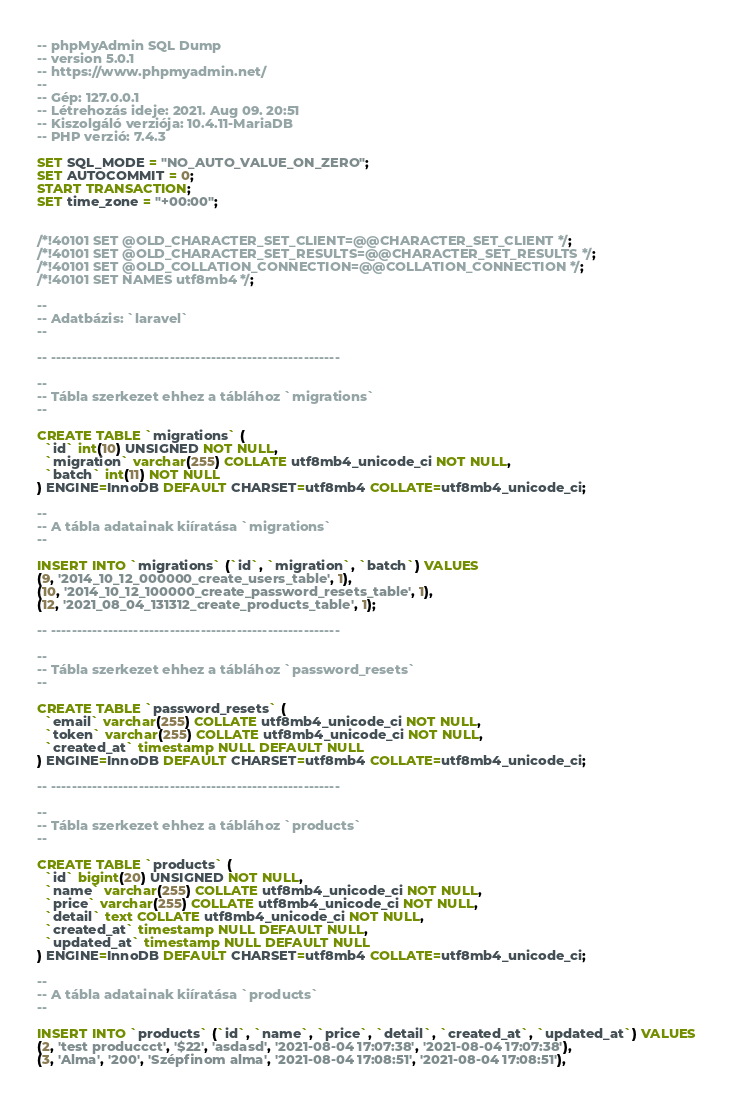<code> <loc_0><loc_0><loc_500><loc_500><_SQL_>-- phpMyAdmin SQL Dump
-- version 5.0.1
-- https://www.phpmyadmin.net/
--
-- Gép: 127.0.0.1
-- Létrehozás ideje: 2021. Aug 09. 20:51
-- Kiszolgáló verziója: 10.4.11-MariaDB
-- PHP verzió: 7.4.3

SET SQL_MODE = "NO_AUTO_VALUE_ON_ZERO";
SET AUTOCOMMIT = 0;
START TRANSACTION;
SET time_zone = "+00:00";


/*!40101 SET @OLD_CHARACTER_SET_CLIENT=@@CHARACTER_SET_CLIENT */;
/*!40101 SET @OLD_CHARACTER_SET_RESULTS=@@CHARACTER_SET_RESULTS */;
/*!40101 SET @OLD_COLLATION_CONNECTION=@@COLLATION_CONNECTION */;
/*!40101 SET NAMES utf8mb4 */;

--
-- Adatbázis: `laravel`
--

-- --------------------------------------------------------

--
-- Tábla szerkezet ehhez a táblához `migrations`
--

CREATE TABLE `migrations` (
  `id` int(10) UNSIGNED NOT NULL,
  `migration` varchar(255) COLLATE utf8mb4_unicode_ci NOT NULL,
  `batch` int(11) NOT NULL
) ENGINE=InnoDB DEFAULT CHARSET=utf8mb4 COLLATE=utf8mb4_unicode_ci;

--
-- A tábla adatainak kiíratása `migrations`
--

INSERT INTO `migrations` (`id`, `migration`, `batch`) VALUES
(9, '2014_10_12_000000_create_users_table', 1),
(10, '2014_10_12_100000_create_password_resets_table', 1),
(12, '2021_08_04_131312_create_products_table', 1);

-- --------------------------------------------------------

--
-- Tábla szerkezet ehhez a táblához `password_resets`
--

CREATE TABLE `password_resets` (
  `email` varchar(255) COLLATE utf8mb4_unicode_ci NOT NULL,
  `token` varchar(255) COLLATE utf8mb4_unicode_ci NOT NULL,
  `created_at` timestamp NULL DEFAULT NULL
) ENGINE=InnoDB DEFAULT CHARSET=utf8mb4 COLLATE=utf8mb4_unicode_ci;

-- --------------------------------------------------------

--
-- Tábla szerkezet ehhez a táblához `products`
--

CREATE TABLE `products` (
  `id` bigint(20) UNSIGNED NOT NULL,
  `name` varchar(255) COLLATE utf8mb4_unicode_ci NOT NULL,
  `price` varchar(255) COLLATE utf8mb4_unicode_ci NOT NULL,
  `detail` text COLLATE utf8mb4_unicode_ci NOT NULL,
  `created_at` timestamp NULL DEFAULT NULL,
  `updated_at` timestamp NULL DEFAULT NULL
) ENGINE=InnoDB DEFAULT CHARSET=utf8mb4 COLLATE=utf8mb4_unicode_ci;

--
-- A tábla adatainak kiíratása `products`
--

INSERT INTO `products` (`id`, `name`, `price`, `detail`, `created_at`, `updated_at`) VALUES
(2, 'test produccct', '$22', 'asdasd', '2021-08-04 17:07:38', '2021-08-04 17:07:38'),
(3, 'Alma', '200', 'Szépfinom alma', '2021-08-04 17:08:51', '2021-08-04 17:08:51'),</code> 